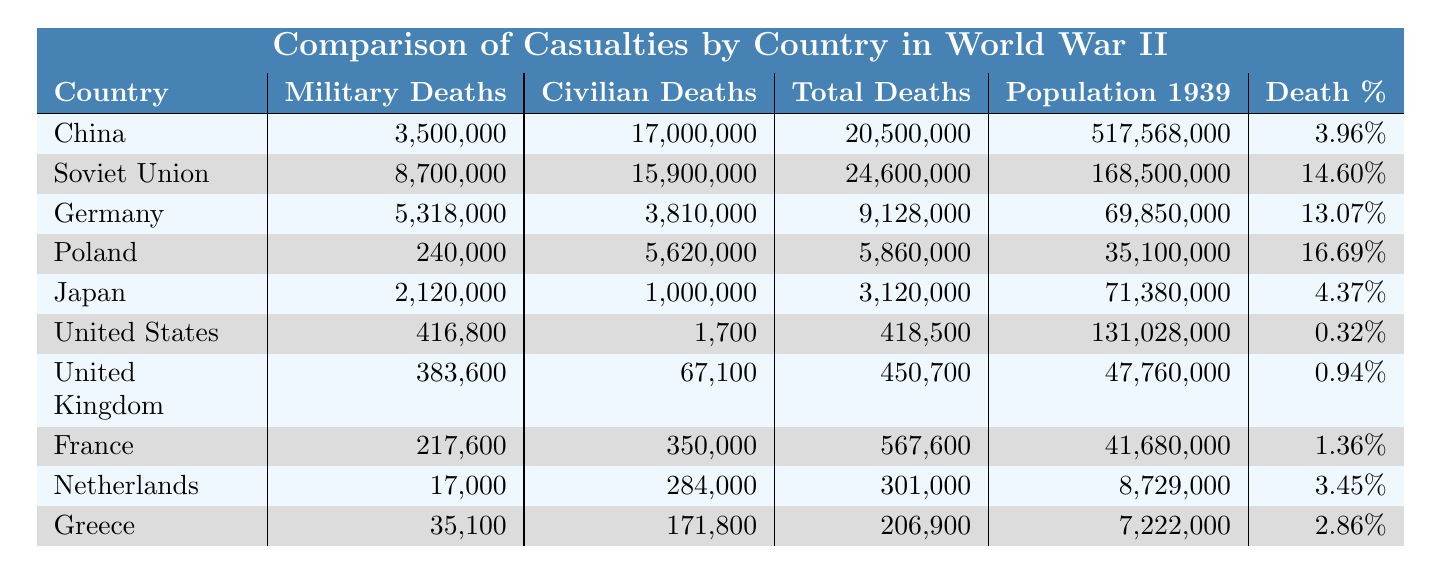What country had the highest number of civilian deaths in World War II? The table shows that the Soviet Union had 15,900,000 civilian deaths, which is the highest among all countries listed.
Answer: Soviet Union What is the total number of deaths for Poland? According to the table, the total deaths for Poland are listed as 5,860,000.
Answer: 5,860,000 Which country had the lowest death percentage? The United States had a death percentage of 0.32%, which is the lowest in the table.
Answer: United States How many more military deaths did the Soviet Union have compared to Germany? The Soviet Union had 8,700,000 military deaths, while Germany had 5,318,000 military deaths. The difference is 8,700,000 - 5,318,000 = 3,382,000.
Answer: 3,382,000 What is the average total deaths among the countries listed? To find the average, sum all total deaths (20,500,000 + 24,600,000 + 9,128,000 + 5,860,000 + 3,120,000 + 418,500 + 450,700 + 567,600 + 301,000 + 206,900) = 74,130,700, and divide by the number of countries (10). The average is 74,130,700 / 10 = 7,413,070.
Answer: 7,413,070 Is it true that China had more civilian deaths than Germany? Yes, according to the table, China had 17,000,000 civilian deaths while Germany had 3,810,000 civilian deaths, so the statement is true.
Answer: Yes Which country suffered the highest percentage of deaths relative to its 1939 population? The country with the highest death percentage is Poland at 16.69%.
Answer: Poland If we combine the military deaths of Japan and Germany, how many total military deaths do they have? Japan's military deaths are 2,120,000 and Germany's are 5,318,000. Summing these gives 2,120,000 + 5,318,000 = 7,438,000.
Answer: 7,438,000 What percentage of the total deaths in Germany were civilians? Germany had a total of 9,128,000 deaths, with 3,810,000 of these being civilian deaths. To calculate the percentage, (3,810,000 / 9,128,000) * 100 = 41.7%.
Answer: 41.7% Which country had the highest number of total deaths among the listed nations? The Soviet Union had the highest total deaths, at 24,600,000, according to the table.
Answer: Soviet Union How many countries had a total of over 5 million deaths? According to the table, the countries with over 5 million deaths are the Soviet Union (24,600,000), China (20,500,000), and Poland (5,860,000), totaling three countries.
Answer: 3 